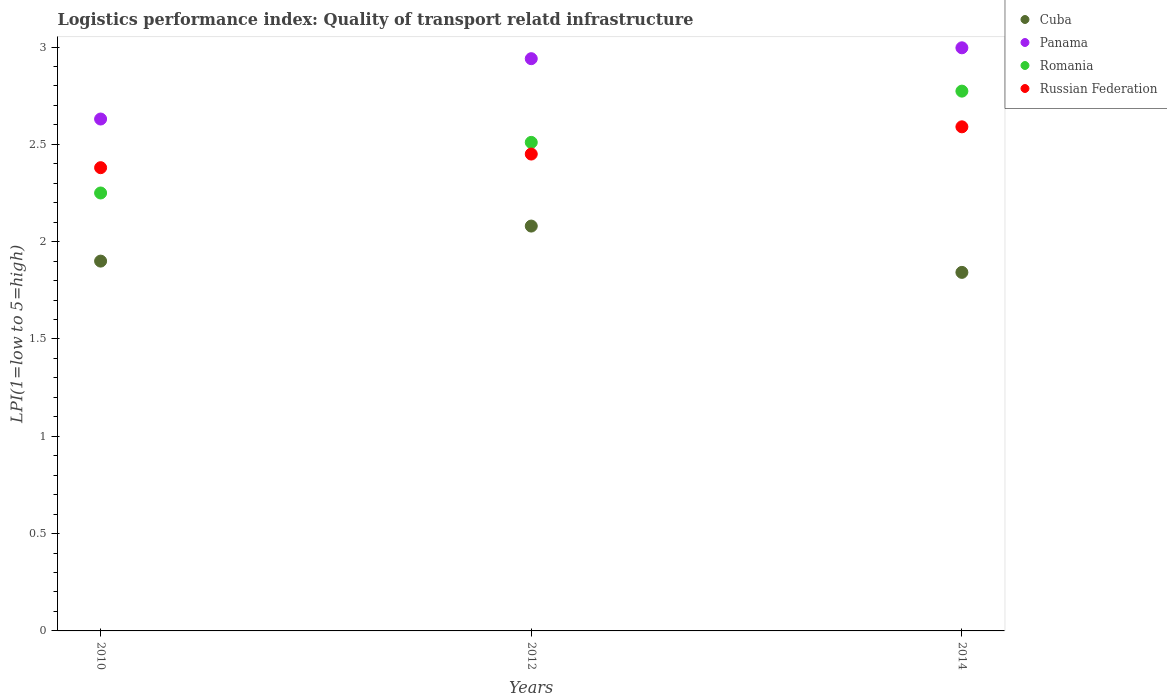How many different coloured dotlines are there?
Keep it short and to the point. 4. Is the number of dotlines equal to the number of legend labels?
Make the answer very short. Yes. What is the logistics performance index in Cuba in 2012?
Your response must be concise. 2.08. Across all years, what is the maximum logistics performance index in Romania?
Provide a short and direct response. 2.77. Across all years, what is the minimum logistics performance index in Romania?
Provide a succinct answer. 2.25. In which year was the logistics performance index in Cuba maximum?
Keep it short and to the point. 2012. What is the total logistics performance index in Panama in the graph?
Offer a terse response. 8.57. What is the difference between the logistics performance index in Russian Federation in 2010 and that in 2012?
Make the answer very short. -0.07. What is the difference between the logistics performance index in Panama in 2014 and the logistics performance index in Romania in 2012?
Give a very brief answer. 0.49. What is the average logistics performance index in Romania per year?
Ensure brevity in your answer.  2.51. In the year 2014, what is the difference between the logistics performance index in Romania and logistics performance index in Panama?
Give a very brief answer. -0.22. In how many years, is the logistics performance index in Panama greater than 0.2?
Offer a terse response. 3. What is the ratio of the logistics performance index in Romania in 2012 to that in 2014?
Your answer should be compact. 0.91. Is the logistics performance index in Cuba in 2010 less than that in 2014?
Ensure brevity in your answer.  No. Is the difference between the logistics performance index in Romania in 2010 and 2012 greater than the difference between the logistics performance index in Panama in 2010 and 2012?
Give a very brief answer. Yes. What is the difference between the highest and the second highest logistics performance index in Romania?
Your response must be concise. 0.26. What is the difference between the highest and the lowest logistics performance index in Romania?
Offer a very short reply. 0.52. Is the sum of the logistics performance index in Russian Federation in 2010 and 2012 greater than the maximum logistics performance index in Panama across all years?
Keep it short and to the point. Yes. Is it the case that in every year, the sum of the logistics performance index in Romania and logistics performance index in Russian Federation  is greater than the sum of logistics performance index in Cuba and logistics performance index in Panama?
Give a very brief answer. No. How many dotlines are there?
Ensure brevity in your answer.  4. Does the graph contain any zero values?
Make the answer very short. No. Does the graph contain grids?
Make the answer very short. No. How are the legend labels stacked?
Provide a short and direct response. Vertical. What is the title of the graph?
Offer a very short reply. Logistics performance index: Quality of transport relatd infrastructure. Does "Serbia" appear as one of the legend labels in the graph?
Provide a succinct answer. No. What is the label or title of the Y-axis?
Offer a terse response. LPI(1=low to 5=high). What is the LPI(1=low to 5=high) in Panama in 2010?
Your response must be concise. 2.63. What is the LPI(1=low to 5=high) in Romania in 2010?
Make the answer very short. 2.25. What is the LPI(1=low to 5=high) of Russian Federation in 2010?
Your answer should be compact. 2.38. What is the LPI(1=low to 5=high) in Cuba in 2012?
Provide a short and direct response. 2.08. What is the LPI(1=low to 5=high) in Panama in 2012?
Your answer should be very brief. 2.94. What is the LPI(1=low to 5=high) in Romania in 2012?
Your answer should be compact. 2.51. What is the LPI(1=low to 5=high) in Russian Federation in 2012?
Your answer should be very brief. 2.45. What is the LPI(1=low to 5=high) of Cuba in 2014?
Ensure brevity in your answer.  1.84. What is the LPI(1=low to 5=high) in Panama in 2014?
Your answer should be compact. 3. What is the LPI(1=low to 5=high) of Romania in 2014?
Offer a terse response. 2.77. What is the LPI(1=low to 5=high) of Russian Federation in 2014?
Give a very brief answer. 2.59. Across all years, what is the maximum LPI(1=low to 5=high) in Cuba?
Ensure brevity in your answer.  2.08. Across all years, what is the maximum LPI(1=low to 5=high) of Panama?
Provide a short and direct response. 3. Across all years, what is the maximum LPI(1=low to 5=high) of Romania?
Offer a terse response. 2.77. Across all years, what is the maximum LPI(1=low to 5=high) in Russian Federation?
Give a very brief answer. 2.59. Across all years, what is the minimum LPI(1=low to 5=high) of Cuba?
Keep it short and to the point. 1.84. Across all years, what is the minimum LPI(1=low to 5=high) in Panama?
Keep it short and to the point. 2.63. Across all years, what is the minimum LPI(1=low to 5=high) of Romania?
Your response must be concise. 2.25. Across all years, what is the minimum LPI(1=low to 5=high) of Russian Federation?
Offer a terse response. 2.38. What is the total LPI(1=low to 5=high) of Cuba in the graph?
Keep it short and to the point. 5.82. What is the total LPI(1=low to 5=high) of Panama in the graph?
Make the answer very short. 8.57. What is the total LPI(1=low to 5=high) of Romania in the graph?
Provide a succinct answer. 7.53. What is the total LPI(1=low to 5=high) of Russian Federation in the graph?
Provide a succinct answer. 7.42. What is the difference between the LPI(1=low to 5=high) of Cuba in 2010 and that in 2012?
Ensure brevity in your answer.  -0.18. What is the difference between the LPI(1=low to 5=high) of Panama in 2010 and that in 2012?
Your answer should be compact. -0.31. What is the difference between the LPI(1=low to 5=high) of Romania in 2010 and that in 2012?
Your response must be concise. -0.26. What is the difference between the LPI(1=low to 5=high) of Russian Federation in 2010 and that in 2012?
Offer a terse response. -0.07. What is the difference between the LPI(1=low to 5=high) of Cuba in 2010 and that in 2014?
Offer a very short reply. 0.06. What is the difference between the LPI(1=low to 5=high) in Panama in 2010 and that in 2014?
Offer a terse response. -0.37. What is the difference between the LPI(1=low to 5=high) in Romania in 2010 and that in 2014?
Offer a terse response. -0.52. What is the difference between the LPI(1=low to 5=high) in Russian Federation in 2010 and that in 2014?
Keep it short and to the point. -0.21. What is the difference between the LPI(1=low to 5=high) in Cuba in 2012 and that in 2014?
Make the answer very short. 0.24. What is the difference between the LPI(1=low to 5=high) in Panama in 2012 and that in 2014?
Your answer should be very brief. -0.06. What is the difference between the LPI(1=low to 5=high) of Romania in 2012 and that in 2014?
Your response must be concise. -0.26. What is the difference between the LPI(1=low to 5=high) of Russian Federation in 2012 and that in 2014?
Offer a terse response. -0.14. What is the difference between the LPI(1=low to 5=high) of Cuba in 2010 and the LPI(1=low to 5=high) of Panama in 2012?
Offer a terse response. -1.04. What is the difference between the LPI(1=low to 5=high) in Cuba in 2010 and the LPI(1=low to 5=high) in Romania in 2012?
Your answer should be very brief. -0.61. What is the difference between the LPI(1=low to 5=high) in Cuba in 2010 and the LPI(1=low to 5=high) in Russian Federation in 2012?
Provide a succinct answer. -0.55. What is the difference between the LPI(1=low to 5=high) in Panama in 2010 and the LPI(1=low to 5=high) in Romania in 2012?
Your response must be concise. 0.12. What is the difference between the LPI(1=low to 5=high) of Panama in 2010 and the LPI(1=low to 5=high) of Russian Federation in 2012?
Offer a very short reply. 0.18. What is the difference between the LPI(1=low to 5=high) of Cuba in 2010 and the LPI(1=low to 5=high) of Panama in 2014?
Offer a very short reply. -1.1. What is the difference between the LPI(1=low to 5=high) in Cuba in 2010 and the LPI(1=low to 5=high) in Romania in 2014?
Ensure brevity in your answer.  -0.87. What is the difference between the LPI(1=low to 5=high) of Cuba in 2010 and the LPI(1=low to 5=high) of Russian Federation in 2014?
Offer a terse response. -0.69. What is the difference between the LPI(1=low to 5=high) in Panama in 2010 and the LPI(1=low to 5=high) in Romania in 2014?
Ensure brevity in your answer.  -0.14. What is the difference between the LPI(1=low to 5=high) in Panama in 2010 and the LPI(1=low to 5=high) in Russian Federation in 2014?
Your answer should be compact. 0.04. What is the difference between the LPI(1=low to 5=high) of Romania in 2010 and the LPI(1=low to 5=high) of Russian Federation in 2014?
Your answer should be compact. -0.34. What is the difference between the LPI(1=low to 5=high) in Cuba in 2012 and the LPI(1=low to 5=high) in Panama in 2014?
Your answer should be very brief. -0.92. What is the difference between the LPI(1=low to 5=high) of Cuba in 2012 and the LPI(1=low to 5=high) of Romania in 2014?
Offer a terse response. -0.69. What is the difference between the LPI(1=low to 5=high) in Cuba in 2012 and the LPI(1=low to 5=high) in Russian Federation in 2014?
Provide a succinct answer. -0.51. What is the difference between the LPI(1=low to 5=high) of Panama in 2012 and the LPI(1=low to 5=high) of Russian Federation in 2014?
Keep it short and to the point. 0.35. What is the difference between the LPI(1=low to 5=high) of Romania in 2012 and the LPI(1=low to 5=high) of Russian Federation in 2014?
Keep it short and to the point. -0.08. What is the average LPI(1=low to 5=high) in Cuba per year?
Your answer should be compact. 1.94. What is the average LPI(1=low to 5=high) of Panama per year?
Ensure brevity in your answer.  2.86. What is the average LPI(1=low to 5=high) of Romania per year?
Your answer should be compact. 2.51. What is the average LPI(1=low to 5=high) in Russian Federation per year?
Your response must be concise. 2.47. In the year 2010, what is the difference between the LPI(1=low to 5=high) in Cuba and LPI(1=low to 5=high) in Panama?
Your answer should be compact. -0.73. In the year 2010, what is the difference between the LPI(1=low to 5=high) in Cuba and LPI(1=low to 5=high) in Romania?
Offer a terse response. -0.35. In the year 2010, what is the difference between the LPI(1=low to 5=high) in Cuba and LPI(1=low to 5=high) in Russian Federation?
Provide a succinct answer. -0.48. In the year 2010, what is the difference between the LPI(1=low to 5=high) in Panama and LPI(1=low to 5=high) in Romania?
Ensure brevity in your answer.  0.38. In the year 2010, what is the difference between the LPI(1=low to 5=high) of Romania and LPI(1=low to 5=high) of Russian Federation?
Keep it short and to the point. -0.13. In the year 2012, what is the difference between the LPI(1=low to 5=high) of Cuba and LPI(1=low to 5=high) of Panama?
Offer a very short reply. -0.86. In the year 2012, what is the difference between the LPI(1=low to 5=high) in Cuba and LPI(1=low to 5=high) in Romania?
Make the answer very short. -0.43. In the year 2012, what is the difference between the LPI(1=low to 5=high) in Cuba and LPI(1=low to 5=high) in Russian Federation?
Keep it short and to the point. -0.37. In the year 2012, what is the difference between the LPI(1=low to 5=high) of Panama and LPI(1=low to 5=high) of Romania?
Your answer should be compact. 0.43. In the year 2012, what is the difference between the LPI(1=low to 5=high) of Panama and LPI(1=low to 5=high) of Russian Federation?
Your answer should be compact. 0.49. In the year 2014, what is the difference between the LPI(1=low to 5=high) of Cuba and LPI(1=low to 5=high) of Panama?
Ensure brevity in your answer.  -1.15. In the year 2014, what is the difference between the LPI(1=low to 5=high) in Cuba and LPI(1=low to 5=high) in Romania?
Make the answer very short. -0.93. In the year 2014, what is the difference between the LPI(1=low to 5=high) of Cuba and LPI(1=low to 5=high) of Russian Federation?
Your response must be concise. -0.75. In the year 2014, what is the difference between the LPI(1=low to 5=high) of Panama and LPI(1=low to 5=high) of Romania?
Keep it short and to the point. 0.22. In the year 2014, what is the difference between the LPI(1=low to 5=high) in Panama and LPI(1=low to 5=high) in Russian Federation?
Your response must be concise. 0.41. In the year 2014, what is the difference between the LPI(1=low to 5=high) in Romania and LPI(1=low to 5=high) in Russian Federation?
Your answer should be very brief. 0.18. What is the ratio of the LPI(1=low to 5=high) of Cuba in 2010 to that in 2012?
Offer a very short reply. 0.91. What is the ratio of the LPI(1=low to 5=high) of Panama in 2010 to that in 2012?
Your answer should be compact. 0.89. What is the ratio of the LPI(1=low to 5=high) of Romania in 2010 to that in 2012?
Your response must be concise. 0.9. What is the ratio of the LPI(1=low to 5=high) of Russian Federation in 2010 to that in 2012?
Provide a succinct answer. 0.97. What is the ratio of the LPI(1=low to 5=high) in Cuba in 2010 to that in 2014?
Keep it short and to the point. 1.03. What is the ratio of the LPI(1=low to 5=high) in Panama in 2010 to that in 2014?
Make the answer very short. 0.88. What is the ratio of the LPI(1=low to 5=high) of Romania in 2010 to that in 2014?
Ensure brevity in your answer.  0.81. What is the ratio of the LPI(1=low to 5=high) in Russian Federation in 2010 to that in 2014?
Offer a terse response. 0.92. What is the ratio of the LPI(1=low to 5=high) in Cuba in 2012 to that in 2014?
Give a very brief answer. 1.13. What is the ratio of the LPI(1=low to 5=high) in Panama in 2012 to that in 2014?
Ensure brevity in your answer.  0.98. What is the ratio of the LPI(1=low to 5=high) in Romania in 2012 to that in 2014?
Offer a very short reply. 0.91. What is the ratio of the LPI(1=low to 5=high) in Russian Federation in 2012 to that in 2014?
Give a very brief answer. 0.95. What is the difference between the highest and the second highest LPI(1=low to 5=high) of Cuba?
Keep it short and to the point. 0.18. What is the difference between the highest and the second highest LPI(1=low to 5=high) in Panama?
Your response must be concise. 0.06. What is the difference between the highest and the second highest LPI(1=low to 5=high) of Romania?
Offer a terse response. 0.26. What is the difference between the highest and the second highest LPI(1=low to 5=high) of Russian Federation?
Give a very brief answer. 0.14. What is the difference between the highest and the lowest LPI(1=low to 5=high) in Cuba?
Your answer should be compact. 0.24. What is the difference between the highest and the lowest LPI(1=low to 5=high) of Panama?
Make the answer very short. 0.37. What is the difference between the highest and the lowest LPI(1=low to 5=high) in Romania?
Give a very brief answer. 0.52. What is the difference between the highest and the lowest LPI(1=low to 5=high) of Russian Federation?
Give a very brief answer. 0.21. 